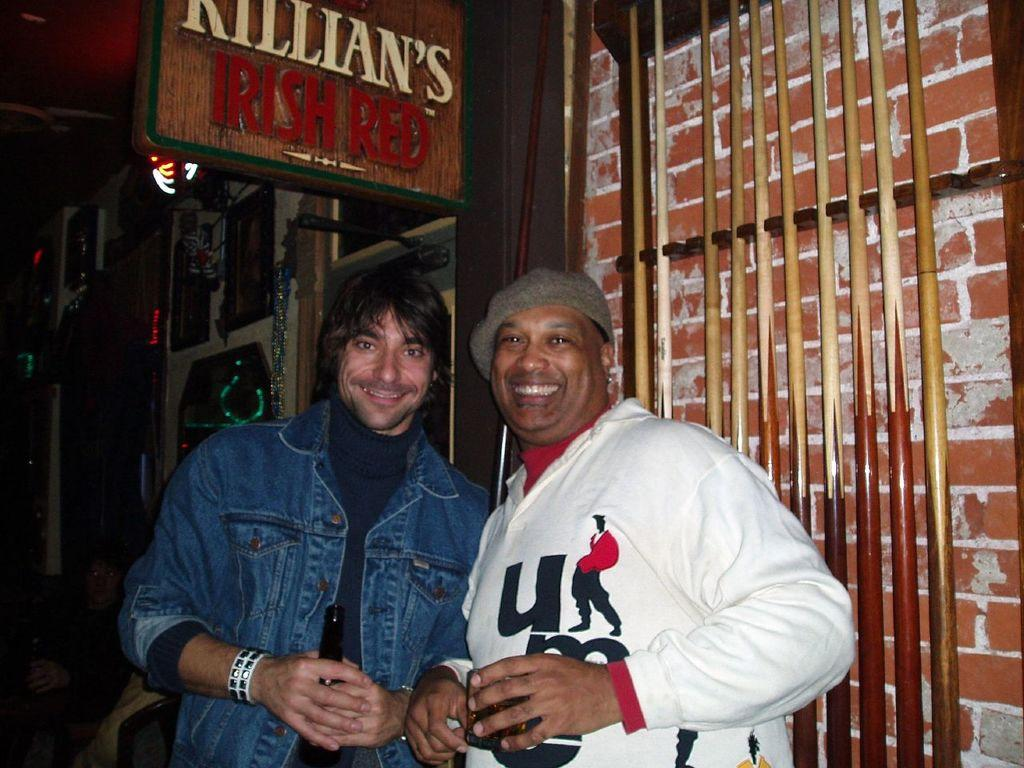<image>
Provide a brief description of the given image. Two men stand beneath a sign for Killian's Irish Red 